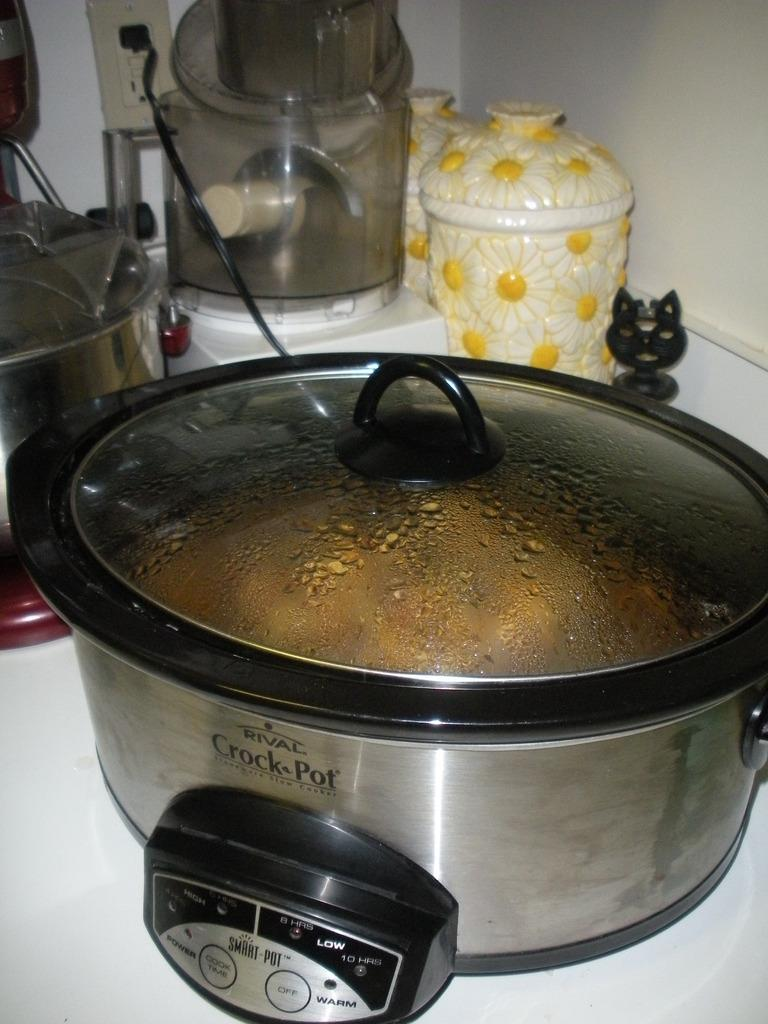Provide a one-sentence caption for the provided image. the crock pot slow cooker with some food with wire connection is placed in front of designer ceramic pot. 